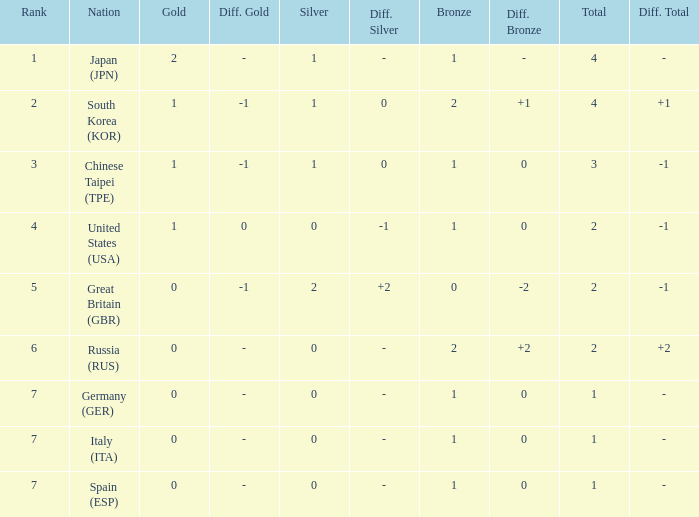How many total medals does a country with more than 1 silver medals have? 2.0. 